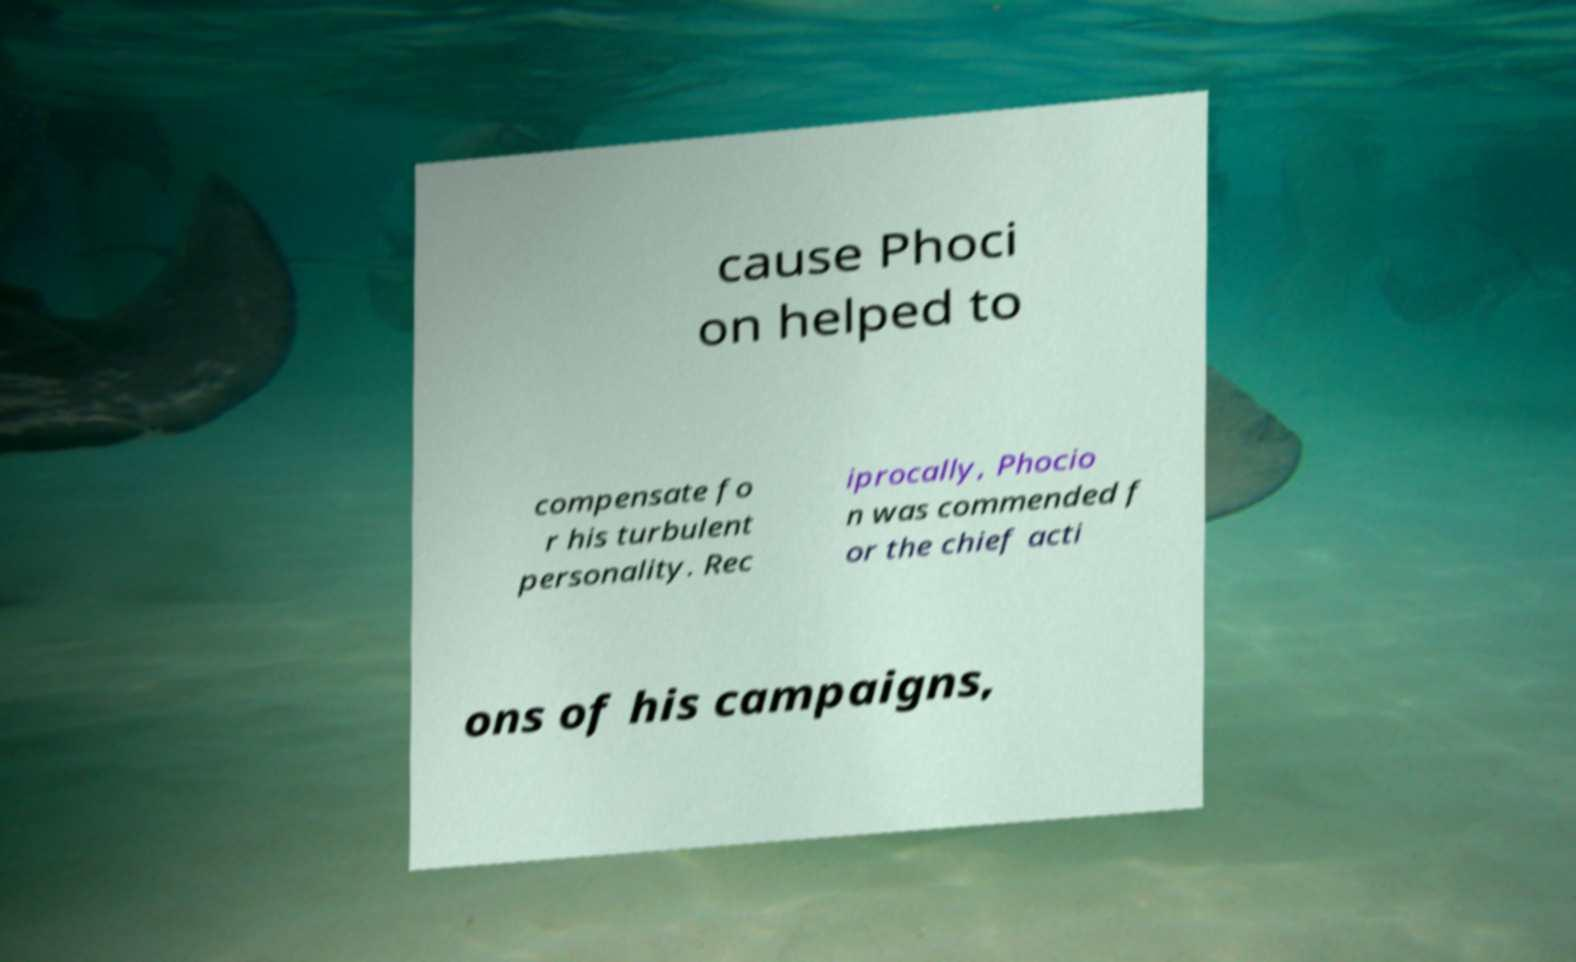Please read and relay the text visible in this image. What does it say? cause Phoci on helped to compensate fo r his turbulent personality. Rec iprocally, Phocio n was commended f or the chief acti ons of his campaigns, 